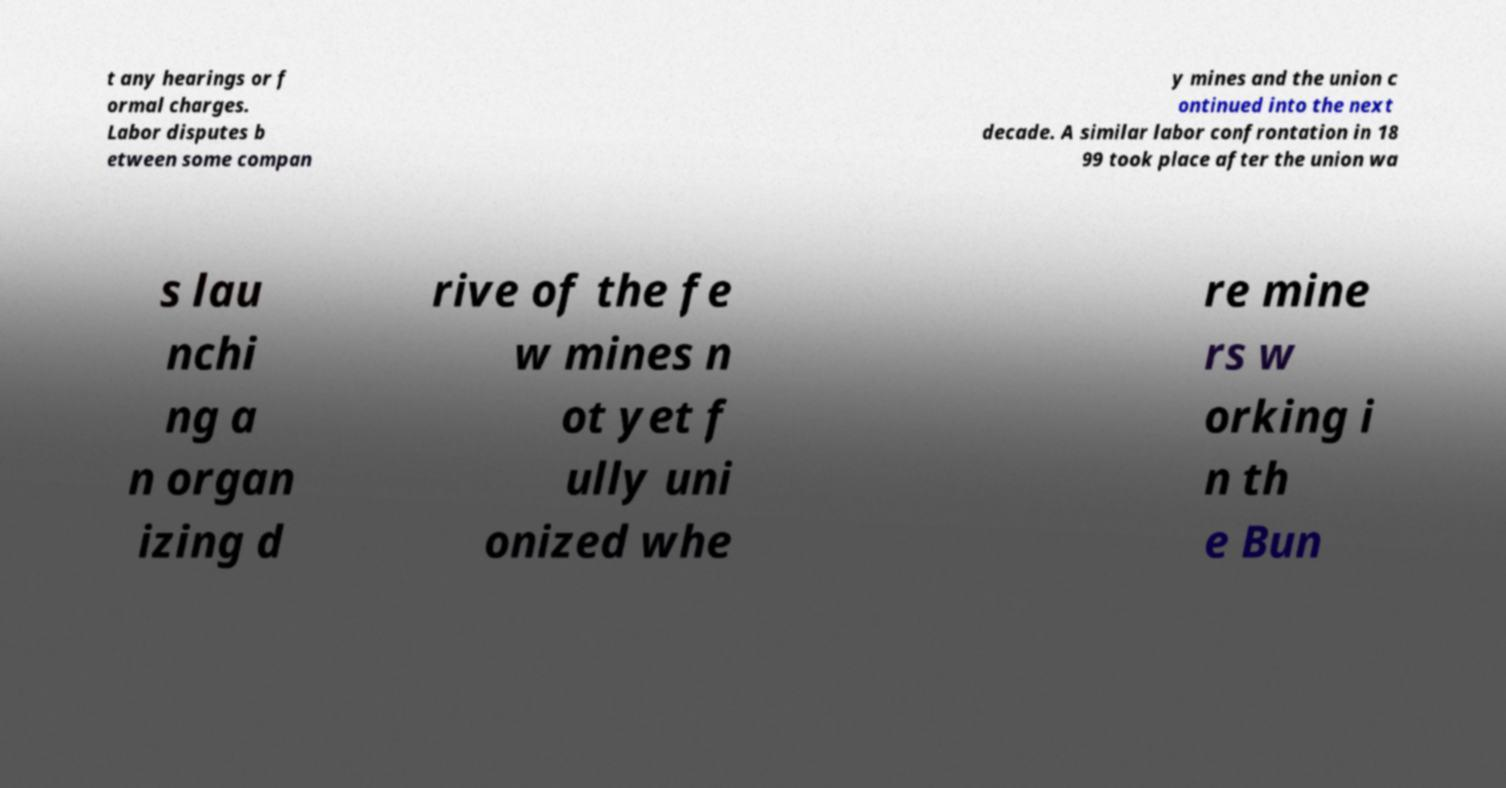What messages or text are displayed in this image? I need them in a readable, typed format. t any hearings or f ormal charges. Labor disputes b etween some compan y mines and the union c ontinued into the next decade. A similar labor confrontation in 18 99 took place after the union wa s lau nchi ng a n organ izing d rive of the fe w mines n ot yet f ully uni onized whe re mine rs w orking i n th e Bun 